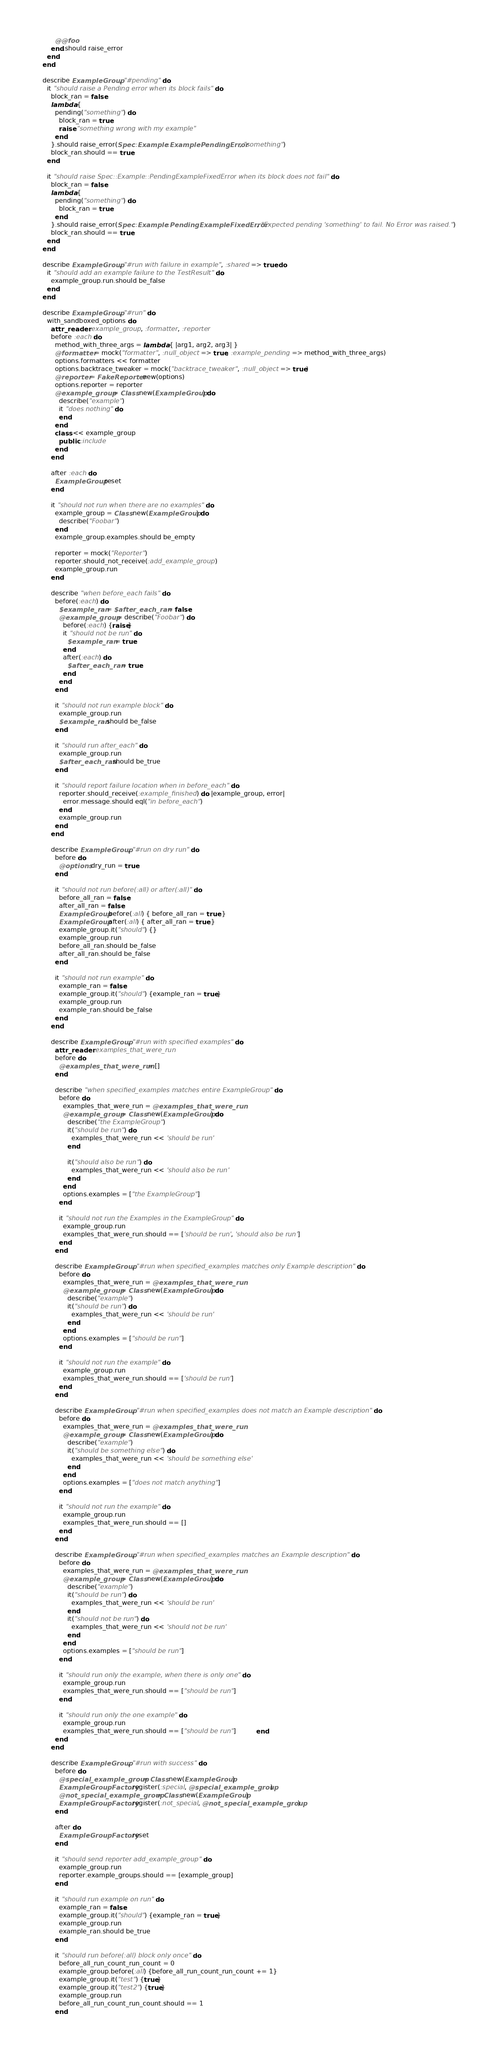<code> <loc_0><loc_0><loc_500><loc_500><_Ruby_>          @@foo
        end.should raise_error
      end
    end

    describe ExampleGroup, "#pending" do
      it "should raise a Pending error when its block fails" do
        block_ran = false
        lambda {
          pending("something") do
            block_ran = true
            raise "something wrong with my example"
          end
        }.should raise_error(Spec::Example::ExamplePendingError, "something")
        block_ran.should == true
      end

      it "should raise Spec::Example::PendingExampleFixedError when its block does not fail" do
        block_ran = false
        lambda {
          pending("something") do
            block_ran = true
          end
        }.should raise_error(Spec::Example::PendingExampleFixedError, "Expected pending 'something' to fail. No Error was raised.")
        block_ran.should == true
      end
    end

    describe ExampleGroup, "#run with failure in example", :shared => true do
      it "should add an example failure to the TestResult" do
        example_group.run.should be_false
      end
    end

    describe ExampleGroup, "#run" do
      with_sandboxed_options do
        attr_reader :example_group, :formatter, :reporter
        before :each do
          method_with_three_args = lambda { |arg1, arg2, arg3| }
          @formatter = mock("formatter", :null_object => true, :example_pending => method_with_three_args)
          options.formatters << formatter
          options.backtrace_tweaker = mock("backtrace_tweaker", :null_object => true)
          @reporter = FakeReporter.new(options)
          options.reporter = reporter
          @example_group = Class.new(ExampleGroup) do
            describe("example")
            it "does nothing" do
            end
          end
          class << example_group
            public :include
          end
        end

        after :each do
          ExampleGroup.reset
        end

        it "should not run when there are no examples" do
          example_group = Class.new(ExampleGroup) do
            describe("Foobar")
          end
          example_group.examples.should be_empty

          reporter = mock("Reporter")
          reporter.should_not_receive(:add_example_group)
          example_group.run
        end
      
        describe "when before_each fails" do
          before(:each) do
            $example_ran = $after_each_ran = false
            @example_group = describe("Foobar") do
              before(:each) {raise}
              it "should not be run" do
                $example_ran = true
              end
              after(:each) do
                $after_each_ran = true
              end
            end
          end

          it "should not run example block" do
            example_group.run
            $example_ran.should be_false
          end
        
          it "should run after_each" do
            example_group.run
            $after_each_ran.should be_true
          end

          it "should report failure location when in before_each" do
            reporter.should_receive(:example_finished) do |example_group, error|
              error.message.should eql("in before_each")
            end
            example_group.run
          end
        end

        describe ExampleGroup, "#run on dry run" do
          before do
            @options.dry_run = true
          end

          it "should not run before(:all) or after(:all)" do
            before_all_ran = false
            after_all_ran = false
            ExampleGroup.before(:all) { before_all_ran = true }
            ExampleGroup.after(:all) { after_all_ran = true }
            example_group.it("should") {}
            example_group.run
            before_all_ran.should be_false
            after_all_ran.should be_false
          end

          it "should not run example" do
            example_ran = false
            example_group.it("should") {example_ran = true}
            example_group.run
            example_ran.should be_false
          end
        end

        describe ExampleGroup, "#run with specified examples" do
          attr_reader :examples_that_were_run
          before do
            @examples_that_were_run = []
          end

          describe "when specified_examples matches entire ExampleGroup" do
            before do
              examples_that_were_run = @examples_that_were_run
              @example_group = Class.new(ExampleGroup) do
                describe("the ExampleGroup")
                it("should be run") do
                  examples_that_were_run << 'should be run'
                end

                it("should also be run") do
                  examples_that_were_run << 'should also be run'
                end
              end
              options.examples = ["the ExampleGroup"]
            end

            it "should not run the Examples in the ExampleGroup" do
              example_group.run
              examples_that_were_run.should == ['should be run', 'should also be run']
            end
          end

          describe ExampleGroup, "#run when specified_examples matches only Example description" do
            before do
              examples_that_were_run = @examples_that_were_run
              @example_group = Class.new(ExampleGroup) do
                describe("example")
                it("should be run") do
                  examples_that_were_run << 'should be run'
                end
              end
              options.examples = ["should be run"]
            end

            it "should not run the example" do
              example_group.run
              examples_that_were_run.should == ['should be run']
            end
          end

          describe ExampleGroup, "#run when specified_examples does not match an Example description" do
            before do
              examples_that_were_run = @examples_that_were_run
              @example_group = Class.new(ExampleGroup) do
                describe("example")
                it("should be something else") do
                  examples_that_were_run << 'should be something else'
                end
              end
              options.examples = ["does not match anything"]
            end

            it "should not run the example" do
              example_group.run
              examples_that_were_run.should == []
            end
          end

          describe ExampleGroup, "#run when specified_examples matches an Example description" do
            before do
              examples_that_were_run = @examples_that_were_run
              @example_group = Class.new(ExampleGroup) do
                describe("example")
                it("should be run") do
                  examples_that_were_run << 'should be run'
                end
                it("should not be run") do
                  examples_that_were_run << 'should not be run'
                end
              end
              options.examples = ["should be run"]
            end

            it "should run only the example, when there is only one" do
              example_group.run
              examples_that_were_run.should == ["should be run"]
            end

            it "should run only the one example" do
              example_group.run
              examples_that_were_run.should == ["should be run"]          end
          end
        end

        describe ExampleGroup, "#run with success" do
          before do
            @special_example_group = Class.new(ExampleGroup)
            ExampleGroupFactory.register(:special, @special_example_group)
            @not_special_example_group = Class.new(ExampleGroup)
            ExampleGroupFactory.register(:not_special, @not_special_example_group)
          end

          after do
            ExampleGroupFactory.reset
          end

          it "should send reporter add_example_group" do
            example_group.run
            reporter.example_groups.should == [example_group]
          end

          it "should run example on run" do
            example_ran = false
            example_group.it("should") {example_ran = true}
            example_group.run
            example_ran.should be_true
          end

          it "should run before(:all) block only once" do
            before_all_run_count_run_count = 0
            example_group.before(:all) {before_all_run_count_run_count += 1}
            example_group.it("test") {true}
            example_group.it("test2") {true}
            example_group.run
            before_all_run_count_run_count.should == 1
          end
</code> 